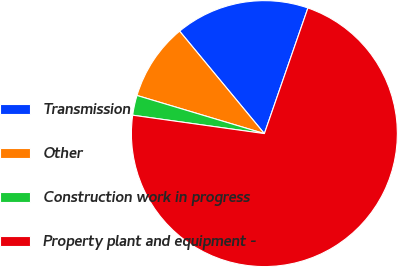<chart> <loc_0><loc_0><loc_500><loc_500><pie_chart><fcel>Transmission<fcel>Other<fcel>Construction work in progress<fcel>Property plant and equipment -<nl><fcel>16.31%<fcel>9.37%<fcel>2.42%<fcel>71.9%<nl></chart> 